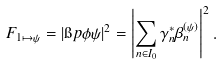<formula> <loc_0><loc_0><loc_500><loc_500>F _ { 1 \mapsto \psi } = | \i p { \phi } { \psi } | ^ { 2 } = \left | \sum _ { n \in I _ { 0 } } \gamma _ { n } ^ { * } \beta _ { n } ^ { ( \psi ) } \right | ^ { 2 } .</formula> 